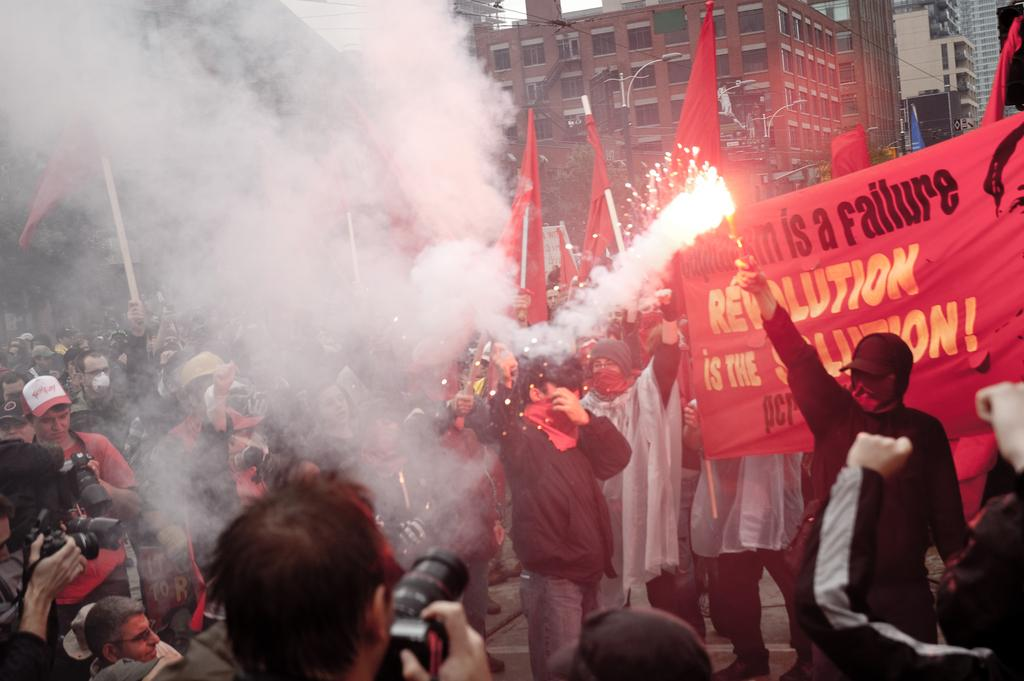<image>
Provide a brief description of the given image. People starting a protest holding signs that say Revolution. 